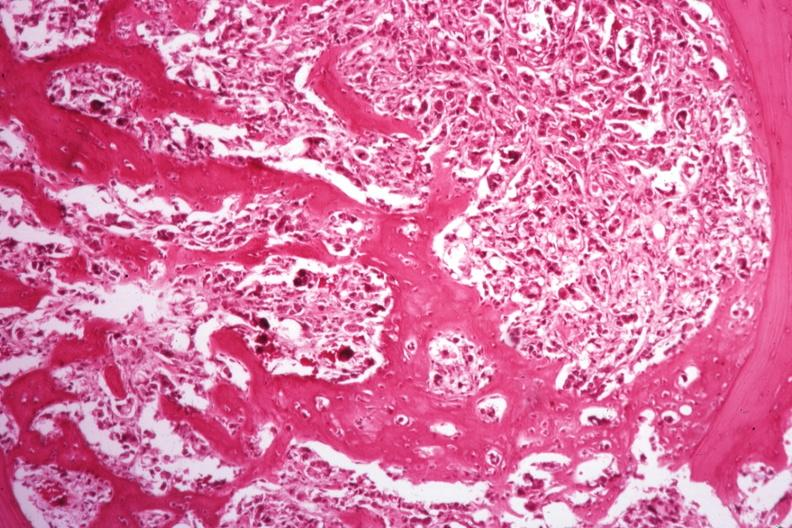s digits present?
Answer the question using a single word or phrase. No 